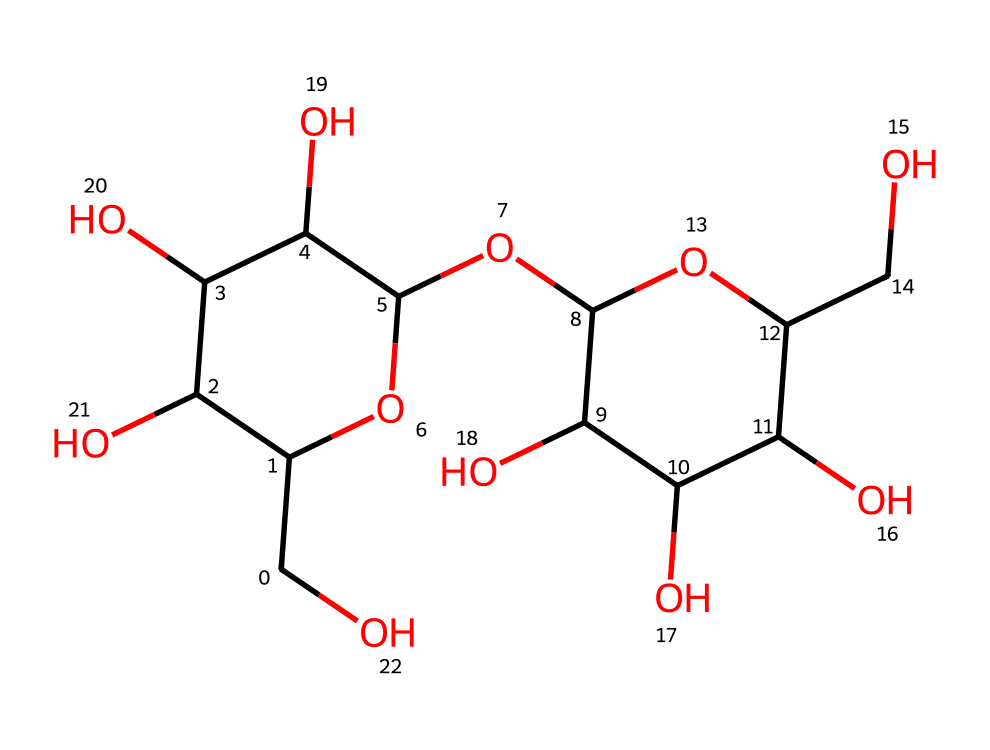How many carbon atoms are present in the structure? By analyzing the SMILES representation, we can count the "C" characters. Each "C" represents a carbon atom, and in this structure, there are 12 carbon atoms.
Answer: 12 What type of molecule is represented by the chemical structure? The structure represents a polysaccharide, specifically cornstarch. Polysaccharides are long chains of sugar units, and cornstarch is primarily composed of glucose units.
Answer: polysaccharide How many hydroxyl (OH) groups are present in this molecule? Hydroxyl groups can be identified by the "O" connected to an "H" or simply the presence of "O" characters in context. By examining the structure, there are 6 hydroxyl groups present.
Answer: 6 What is the primary function of the corn starch molecules in oobleck? Cornstarch in oobleck acts to provide viscosity and creates the unique non-Newtonian fluid behavior by allowing molecules to interact and change their flow under stress.
Answer: viscosity What feature of the chemical structure contributes to its non-Newtonian properties? The presence of branching due to glucan chain structures makes this molecule capable of different flow behaviors under varying stress conditions, a hallmark of non-Newtonian fluids like oobleck.
Answer: branching How many rings are present in the structure? The "C" characters followed by numbers indicate cyclic structures. This SMILES notation shows that there are two ring structures present in the chemical.
Answer: 2 What type of interactions primarily influence the behavior of cornstarch in oobleck? The behavior of cornstarch in oobleck is primarily influenced by hydrogen bonding among the hydroxyl groups, leading to the unique physical properties observed in non-Newtonian fluids.
Answer: hydrogen bonding 